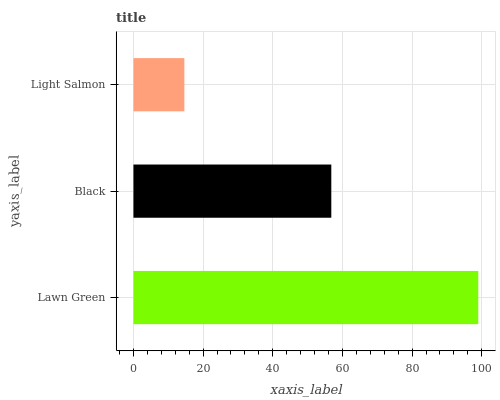Is Light Salmon the minimum?
Answer yes or no. Yes. Is Lawn Green the maximum?
Answer yes or no. Yes. Is Black the minimum?
Answer yes or no. No. Is Black the maximum?
Answer yes or no. No. Is Lawn Green greater than Black?
Answer yes or no. Yes. Is Black less than Lawn Green?
Answer yes or no. Yes. Is Black greater than Lawn Green?
Answer yes or no. No. Is Lawn Green less than Black?
Answer yes or no. No. Is Black the high median?
Answer yes or no. Yes. Is Black the low median?
Answer yes or no. Yes. Is Lawn Green the high median?
Answer yes or no. No. Is Light Salmon the low median?
Answer yes or no. No. 